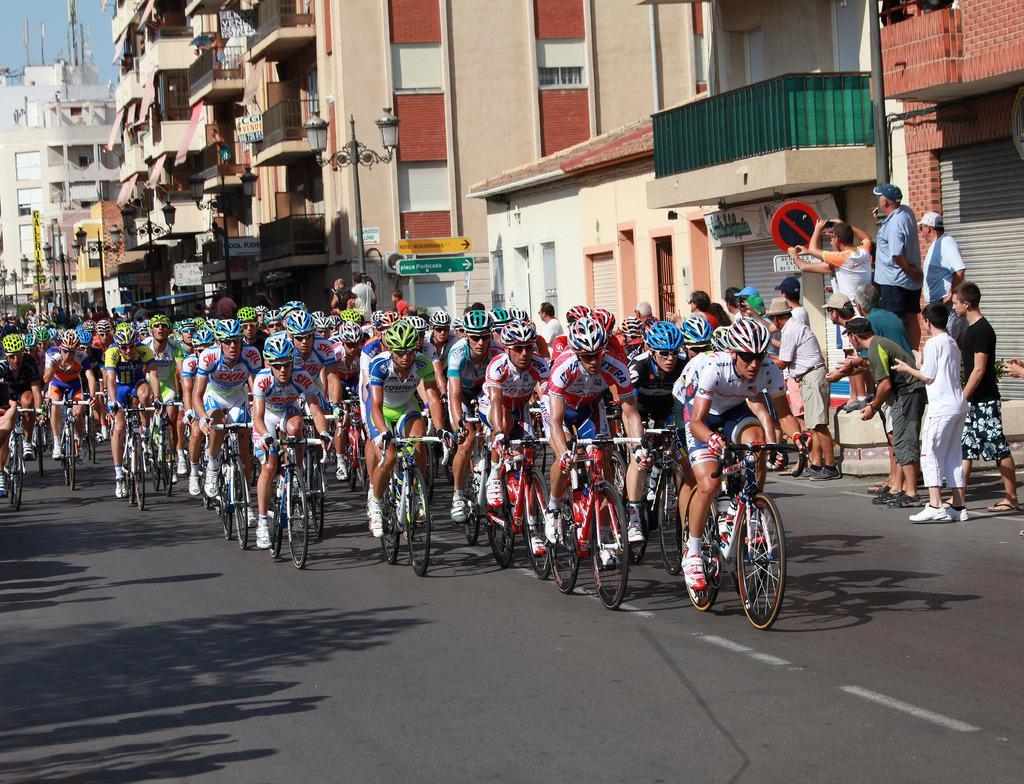Can you describe this image briefly? In this image we can see so many men are riding bicycles on the road. Right side of the image people are cheering and taking photographs. Behind them so many buildings are there. The sky is in blue color. 